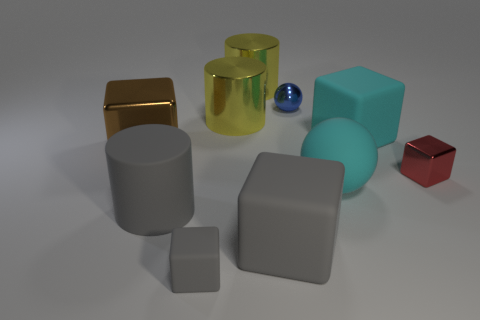There is a brown thing that is the same shape as the red thing; what is its material?
Offer a terse response. Metal. Are any large rubber cylinders visible?
Offer a terse response. Yes. The big gray object that is made of the same material as the big gray block is what shape?
Ensure brevity in your answer.  Cylinder. There is a sphere behind the large matte sphere; what material is it?
Offer a terse response. Metal. Is the color of the matte object right of the large rubber ball the same as the matte sphere?
Your response must be concise. Yes. What size is the metallic cube to the right of the tiny metallic object to the left of the cyan sphere?
Your answer should be very brief. Small. Are there more rubber things to the right of the gray matte cylinder than shiny spheres?
Give a very brief answer. Yes. Does the metallic cube that is on the right side of the blue object have the same size as the large brown metallic thing?
Provide a short and direct response. No. There is a big block that is both behind the big cyan matte sphere and to the left of the cyan sphere; what is its color?
Your answer should be very brief. Brown. The other shiny object that is the same size as the red object is what shape?
Offer a terse response. Sphere. 